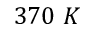Convert formula to latex. <formula><loc_0><loc_0><loc_500><loc_500>3 7 0 K</formula> 